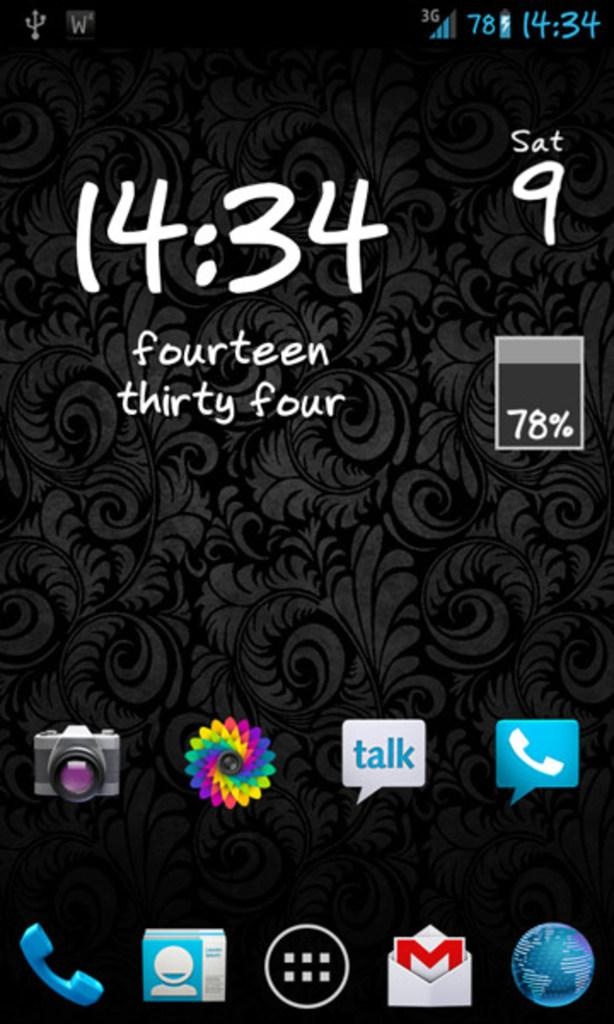<image>
Summarize the visual content of the image. A black phone display shows it only has 78% battery left 